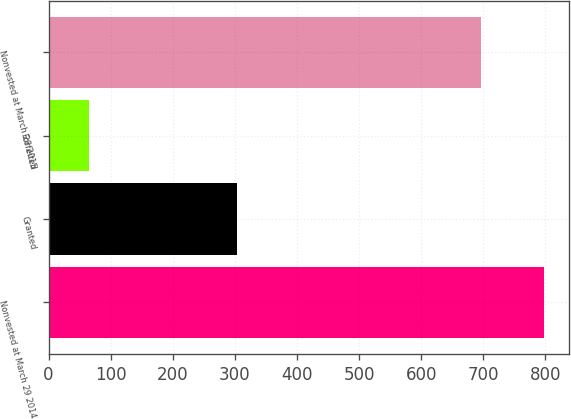Convert chart. <chart><loc_0><loc_0><loc_500><loc_500><bar_chart><fcel>Nonvested at March 29 2014<fcel>Granted<fcel>Forfeited<fcel>Nonvested at March 28 2015<nl><fcel>798<fcel>303<fcel>65<fcel>697<nl></chart> 